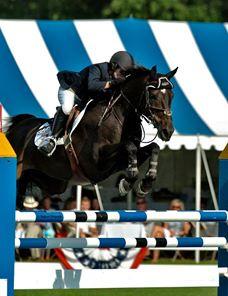What color is the jockey's helmet?
Concise answer only. Black. How many bars is this horse jumping?
Write a very short answer. 2. What color is the tent?
Short answer required. Blue and white. 